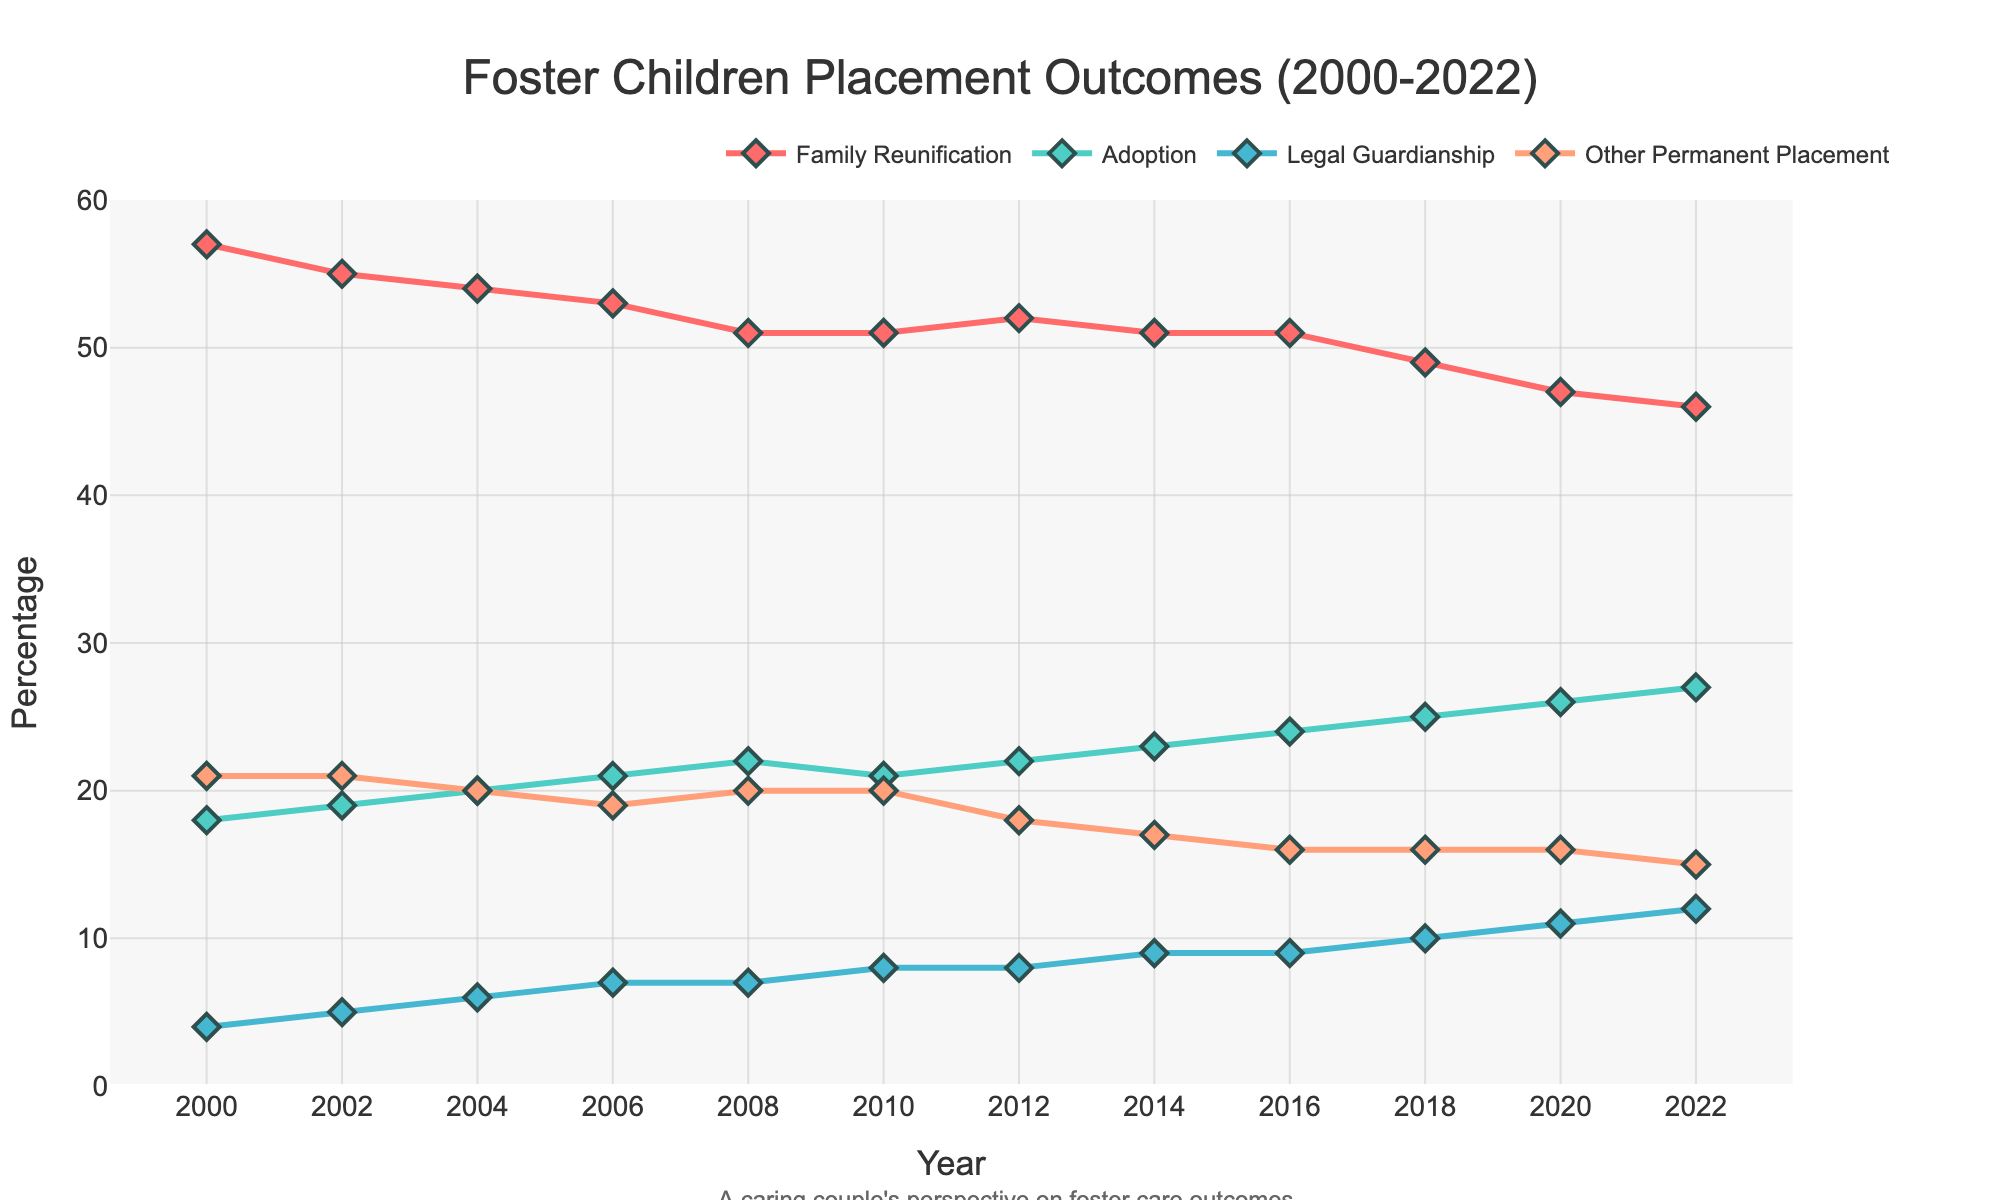what is the overall trend in family reunification rates from 2000 to 2022? The overall trend can be identified by examining the percentage values of family reunification rates over the years. From 2000 to 2022, these rates have consistently decreased. Starting at 57% in 2000, the rates have declined to 46% in 2022.
Answer: Decreasing Which year had the highest adoption rate? Look for the year where the adoption percentage is the highest among all the years. From the data provided, 2022 has the highest adoption rate at 27%.
Answer: 2022 How does the percentage of legal guardianship in 2006 compare to that in 2022? Compare the percentage values for legal guardianship in the specified years. In 2006, it was 7%, and in 2022, it increased to 12%.
Answer: It increased What is the difference in the family reunification rate between 2000 and 2022? Subtract the family reunification rate of 2022 from that of 2000. The rate in 2000 was 57% and in 2022 it was 46%. 57% - 46% = 11%.
Answer: 11% What is the average adoption rate from 2000 to 2022? First, add up the adoption rates for all the years and then divide by the number of years. The sum is (18+19+20+21+22+21+22+23+24+25+26+27) = 268. There are 12 years, so the average is 268/12 ≈ 22.33%.
Answer: 22.33% What year shows the lowest rate of other permanent placements? Identify the year with the lowest percentage in the "Other Permanent Placement" column. From the data, it is 2022 with a rate of 15%.
Answer: 2022 Compare the trend of adoption rates with family reunification rates from 2000 to 2022. To compare the trends, observe both sets of values over the years. Adoption rates show an increasing trend (from 18% to 27%), while family reunification rates show a decreasing trend (from 57% to 46%).
Answer: Adoption increased, Family reunification decreased What's the sum of family reunification rates and adoption rates in 2010? Add the family reunification rate and the adoption rate for 2010. This is 51% + 21% = 72%.
Answer: 72% Between 2000 and 2022, which placement outcome showed the greatest increase in percentage? Calculate the change for each outcome from 2000 to 2022: Family Reunification (57% to 46%, decrease of 11%), Adoption (18% to 27%, increase of 9%), Legal Guardianship (4% to 12%, increase of 8%), and Other Permanent Placement (21% to 15%, decrease of 6%). The greatest increase is in Adoption.
Answer: Adoption (9%) 